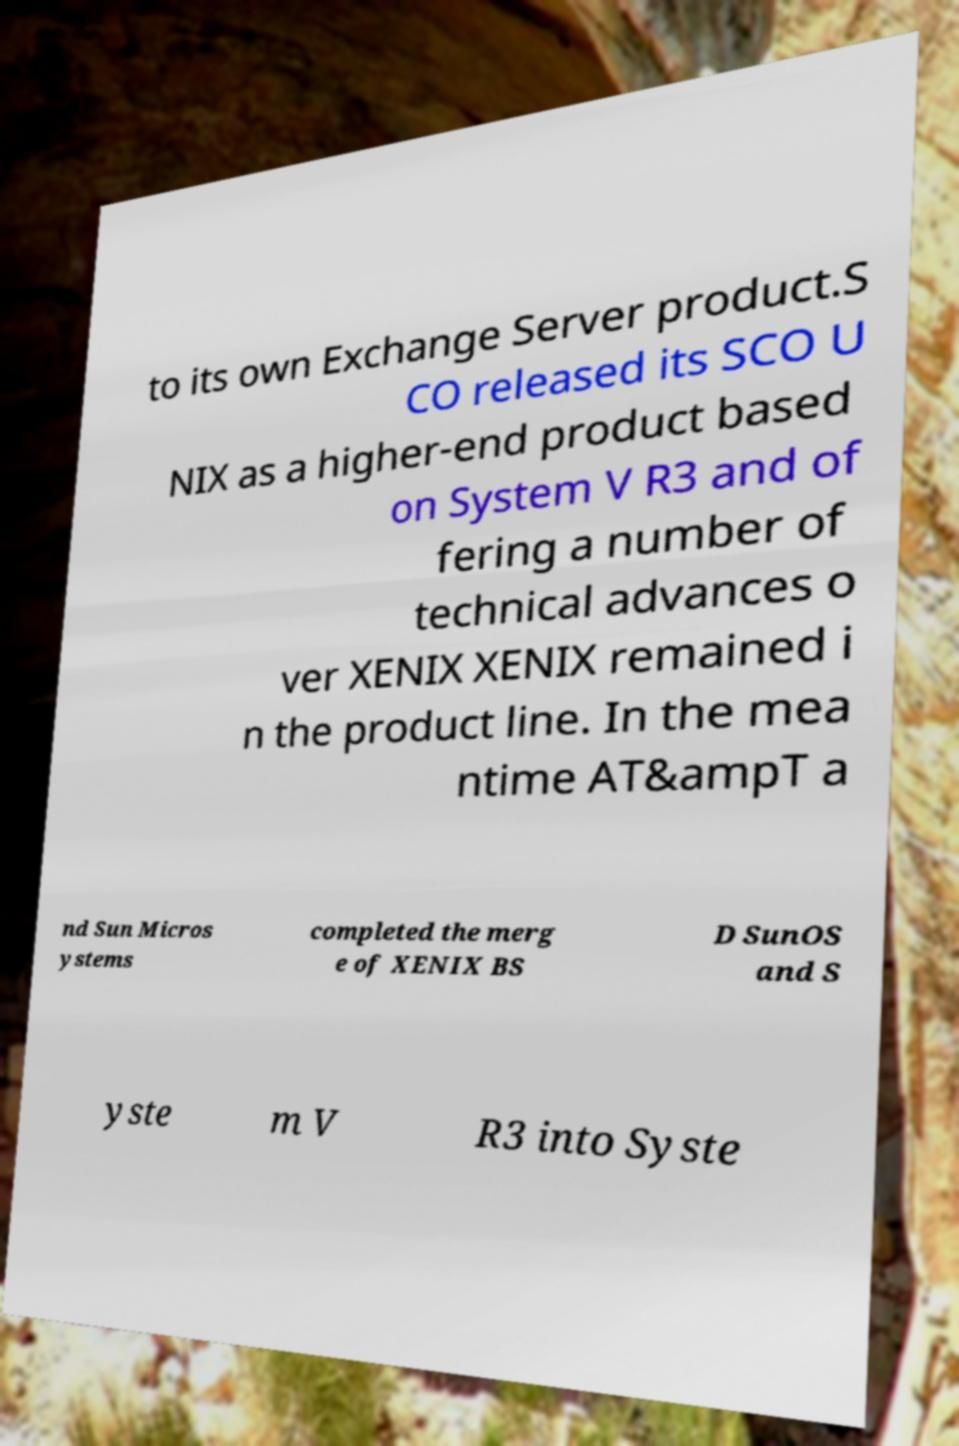I need the written content from this picture converted into text. Can you do that? to its own Exchange Server product.S CO released its SCO U NIX as a higher-end product based on System V R3 and of fering a number of technical advances o ver XENIX XENIX remained i n the product line. In the mea ntime AT&ampT a nd Sun Micros ystems completed the merg e of XENIX BS D SunOS and S yste m V R3 into Syste 